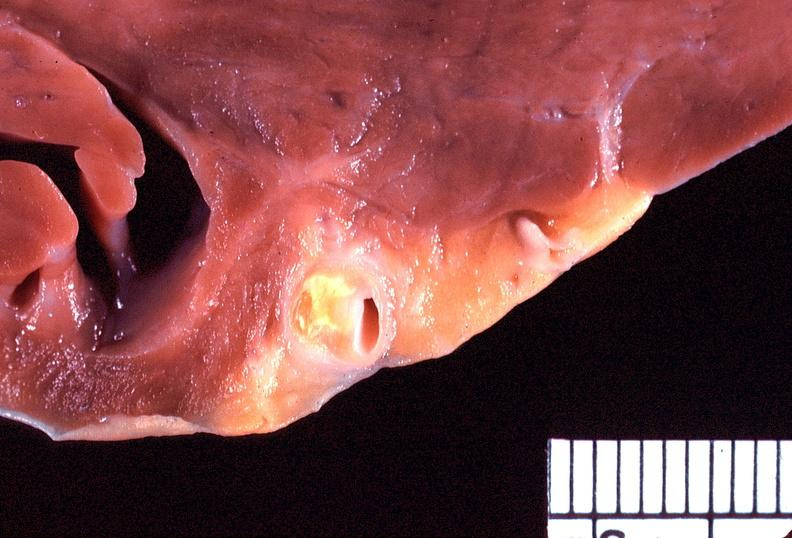what does this image show?
Answer the question using a single word or phrase. Heart 